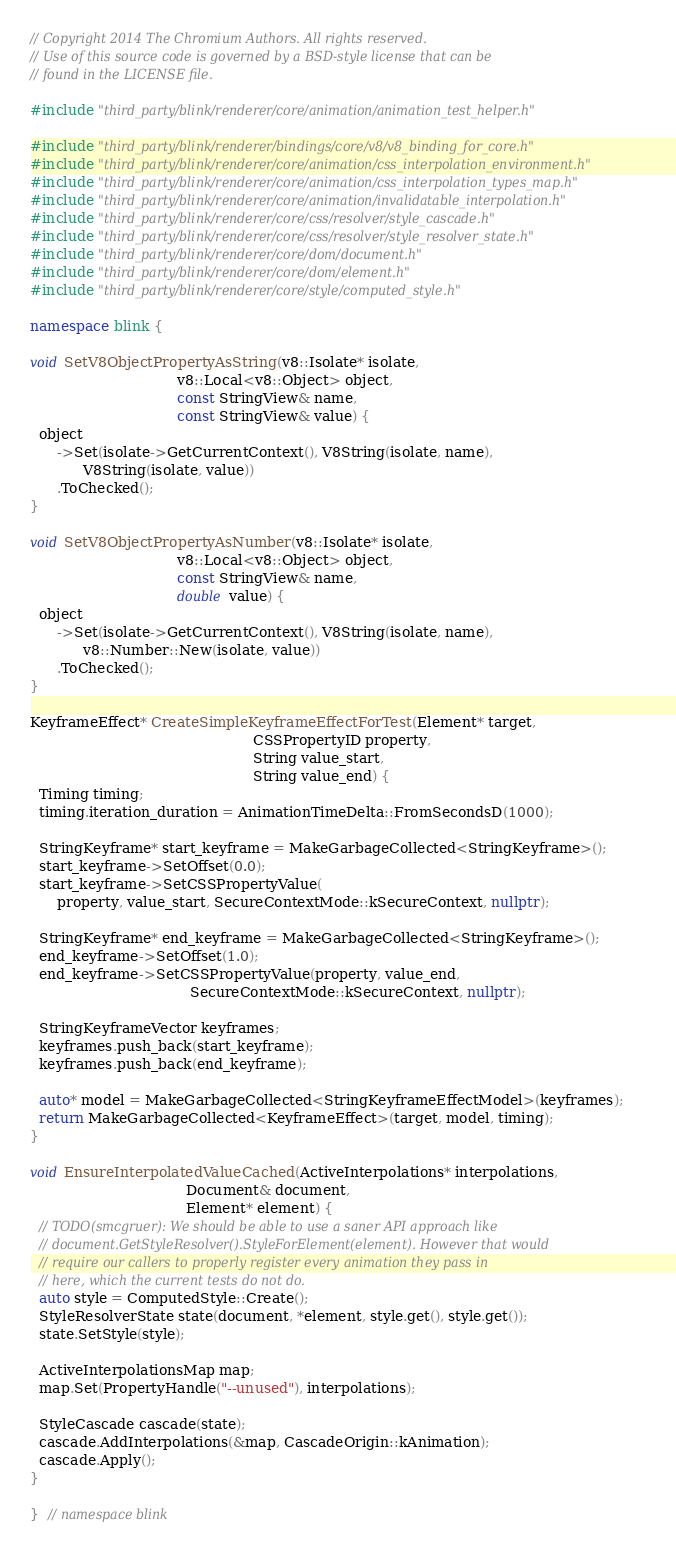Convert code to text. <code><loc_0><loc_0><loc_500><loc_500><_C++_>// Copyright 2014 The Chromium Authors. All rights reserved.
// Use of this source code is governed by a BSD-style license that can be
// found in the LICENSE file.

#include "third_party/blink/renderer/core/animation/animation_test_helper.h"

#include "third_party/blink/renderer/bindings/core/v8/v8_binding_for_core.h"
#include "third_party/blink/renderer/core/animation/css_interpolation_environment.h"
#include "third_party/blink/renderer/core/animation/css_interpolation_types_map.h"
#include "third_party/blink/renderer/core/animation/invalidatable_interpolation.h"
#include "third_party/blink/renderer/core/css/resolver/style_cascade.h"
#include "third_party/blink/renderer/core/css/resolver/style_resolver_state.h"
#include "third_party/blink/renderer/core/dom/document.h"
#include "third_party/blink/renderer/core/dom/element.h"
#include "third_party/blink/renderer/core/style/computed_style.h"

namespace blink {

void SetV8ObjectPropertyAsString(v8::Isolate* isolate,
                                 v8::Local<v8::Object> object,
                                 const StringView& name,
                                 const StringView& value) {
  object
      ->Set(isolate->GetCurrentContext(), V8String(isolate, name),
            V8String(isolate, value))
      .ToChecked();
}

void SetV8ObjectPropertyAsNumber(v8::Isolate* isolate,
                                 v8::Local<v8::Object> object,
                                 const StringView& name,
                                 double value) {
  object
      ->Set(isolate->GetCurrentContext(), V8String(isolate, name),
            v8::Number::New(isolate, value))
      .ToChecked();
}

KeyframeEffect* CreateSimpleKeyframeEffectForTest(Element* target,
                                                  CSSPropertyID property,
                                                  String value_start,
                                                  String value_end) {
  Timing timing;
  timing.iteration_duration = AnimationTimeDelta::FromSecondsD(1000);

  StringKeyframe* start_keyframe = MakeGarbageCollected<StringKeyframe>();
  start_keyframe->SetOffset(0.0);
  start_keyframe->SetCSSPropertyValue(
      property, value_start, SecureContextMode::kSecureContext, nullptr);

  StringKeyframe* end_keyframe = MakeGarbageCollected<StringKeyframe>();
  end_keyframe->SetOffset(1.0);
  end_keyframe->SetCSSPropertyValue(property, value_end,
                                    SecureContextMode::kSecureContext, nullptr);

  StringKeyframeVector keyframes;
  keyframes.push_back(start_keyframe);
  keyframes.push_back(end_keyframe);

  auto* model = MakeGarbageCollected<StringKeyframeEffectModel>(keyframes);
  return MakeGarbageCollected<KeyframeEffect>(target, model, timing);
}

void EnsureInterpolatedValueCached(ActiveInterpolations* interpolations,
                                   Document& document,
                                   Element* element) {
  // TODO(smcgruer): We should be able to use a saner API approach like
  // document.GetStyleResolver().StyleForElement(element). However that would
  // require our callers to properly register every animation they pass in
  // here, which the current tests do not do.
  auto style = ComputedStyle::Create();
  StyleResolverState state(document, *element, style.get(), style.get());
  state.SetStyle(style);

  ActiveInterpolationsMap map;
  map.Set(PropertyHandle("--unused"), interpolations);

  StyleCascade cascade(state);
  cascade.AddInterpolations(&map, CascadeOrigin::kAnimation);
  cascade.Apply();
}

}  // namespace blink
</code> 